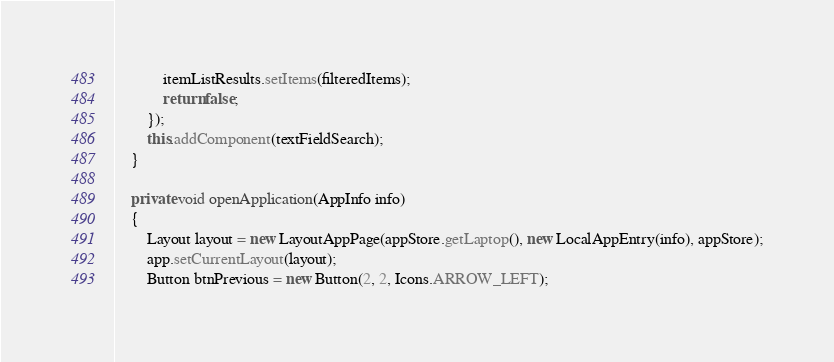<code> <loc_0><loc_0><loc_500><loc_500><_Java_>            itemListResults.setItems(filteredItems);
            return false;
        });
        this.addComponent(textFieldSearch);
    }

    private void openApplication(AppInfo info)
    {
        Layout layout = new LayoutAppPage(appStore.getLaptop(), new LocalAppEntry(info), appStore);
        app.setCurrentLayout(layout);
        Button btnPrevious = new Button(2, 2, Icons.ARROW_LEFT);</code> 